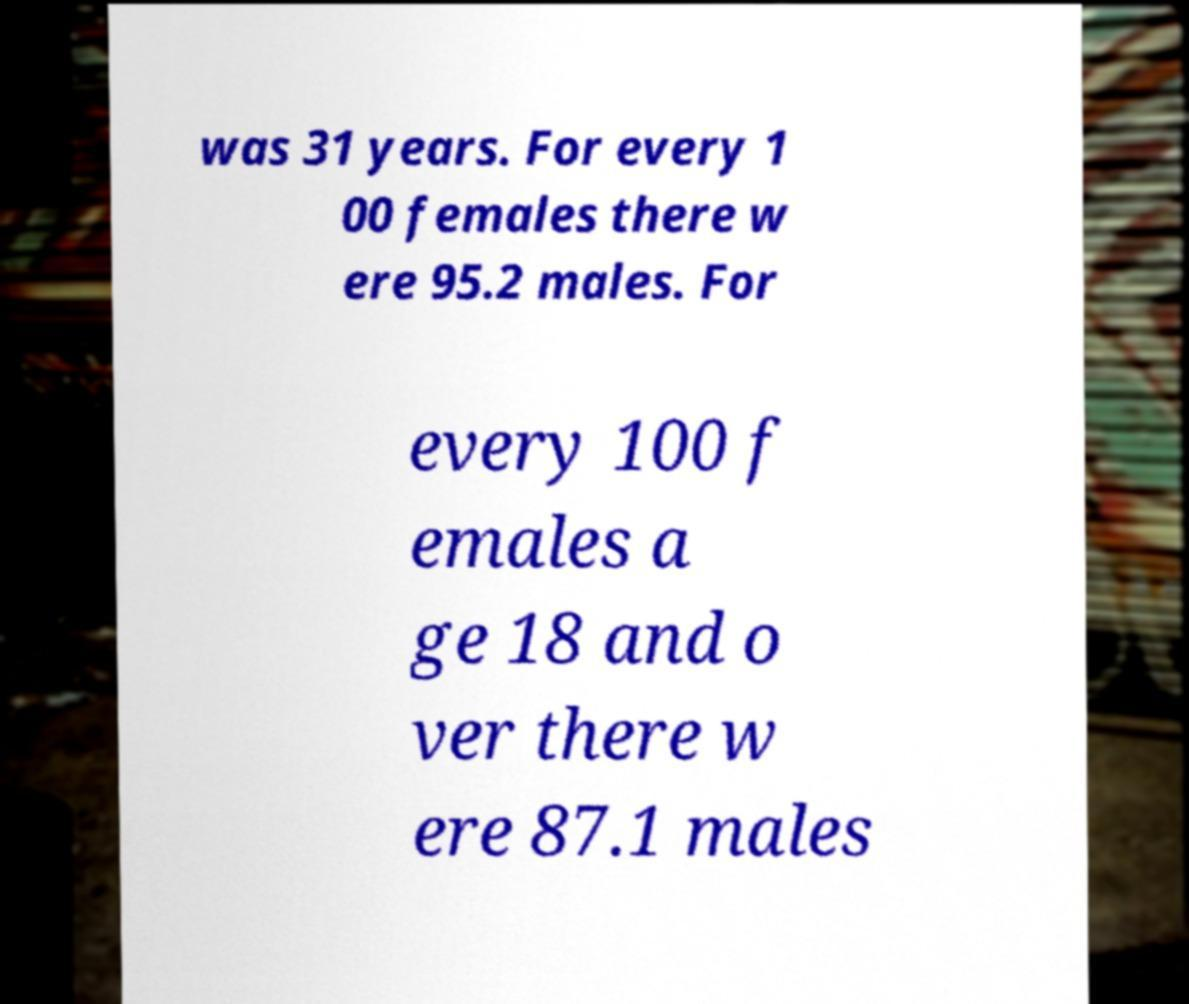What messages or text are displayed in this image? I need them in a readable, typed format. was 31 years. For every 1 00 females there w ere 95.2 males. For every 100 f emales a ge 18 and o ver there w ere 87.1 males 